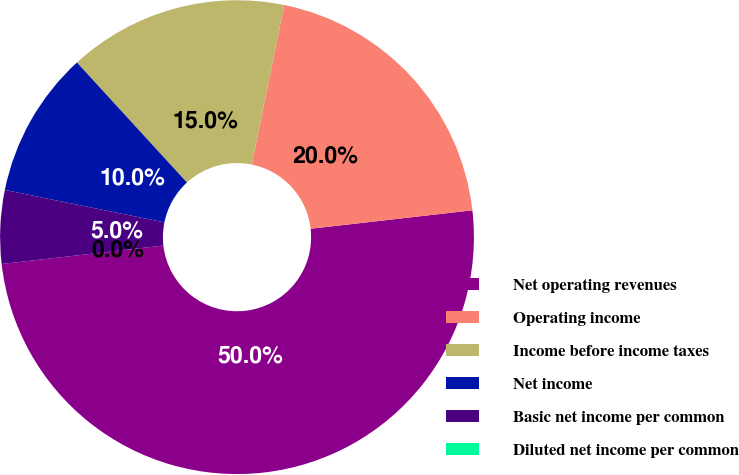Convert chart. <chart><loc_0><loc_0><loc_500><loc_500><pie_chart><fcel>Net operating revenues<fcel>Operating income<fcel>Income before income taxes<fcel>Net income<fcel>Basic net income per common<fcel>Diluted net income per common<nl><fcel>50.0%<fcel>20.0%<fcel>15.0%<fcel>10.0%<fcel>5.0%<fcel>0.0%<nl></chart> 